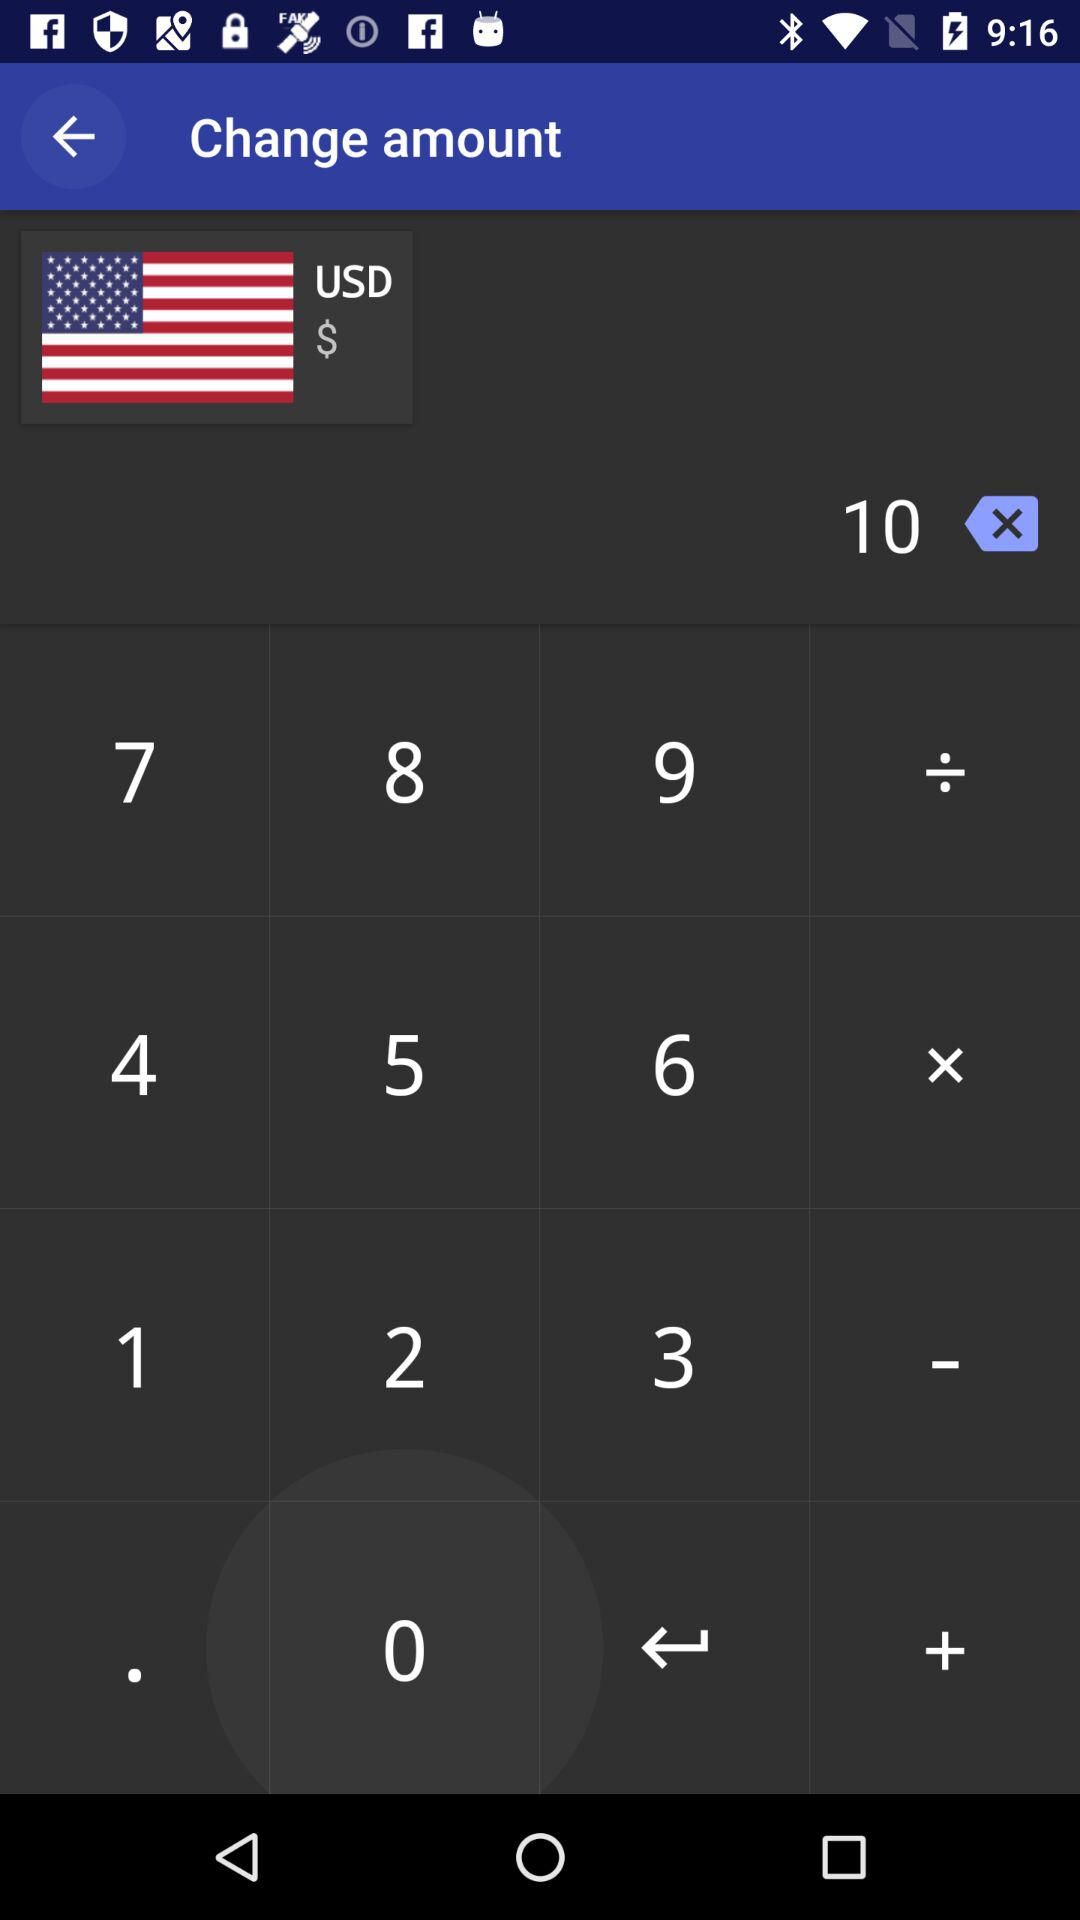Which currency options are available?
When the provided information is insufficient, respond with <no answer>. <no answer> 